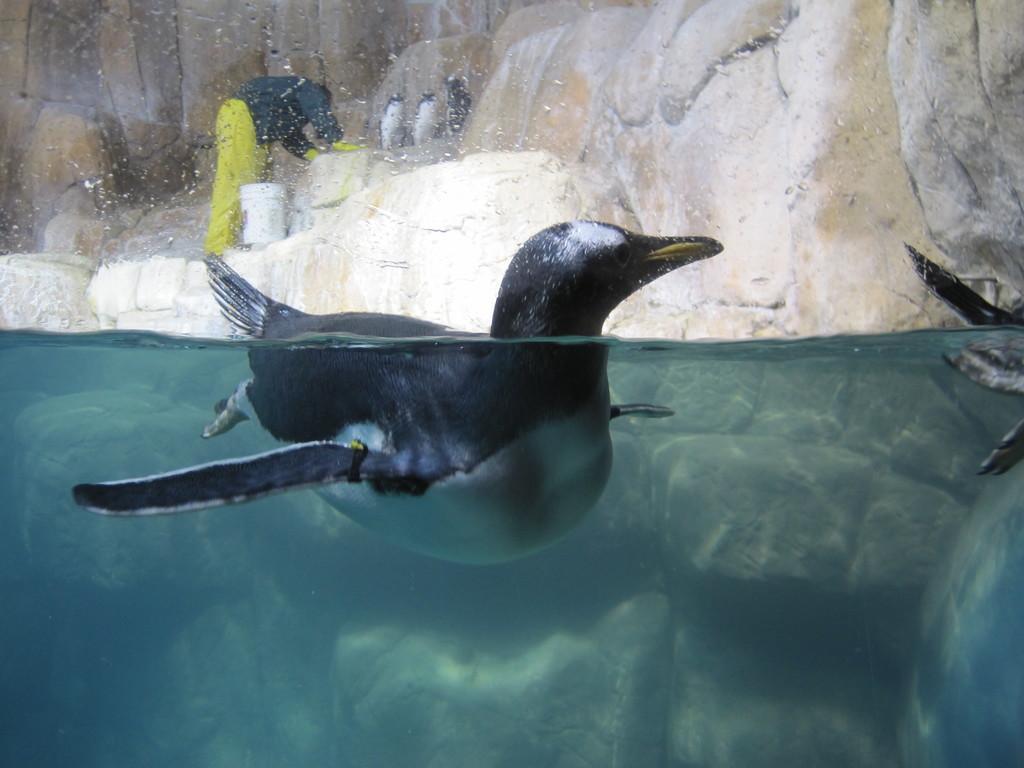In one or two sentences, can you explain what this image depicts? In this image an aquatic animal is swimming in water. A person is standing on the rock. A bucket is beside him. Few animals are on the rock. Right side there is an animal in water. 